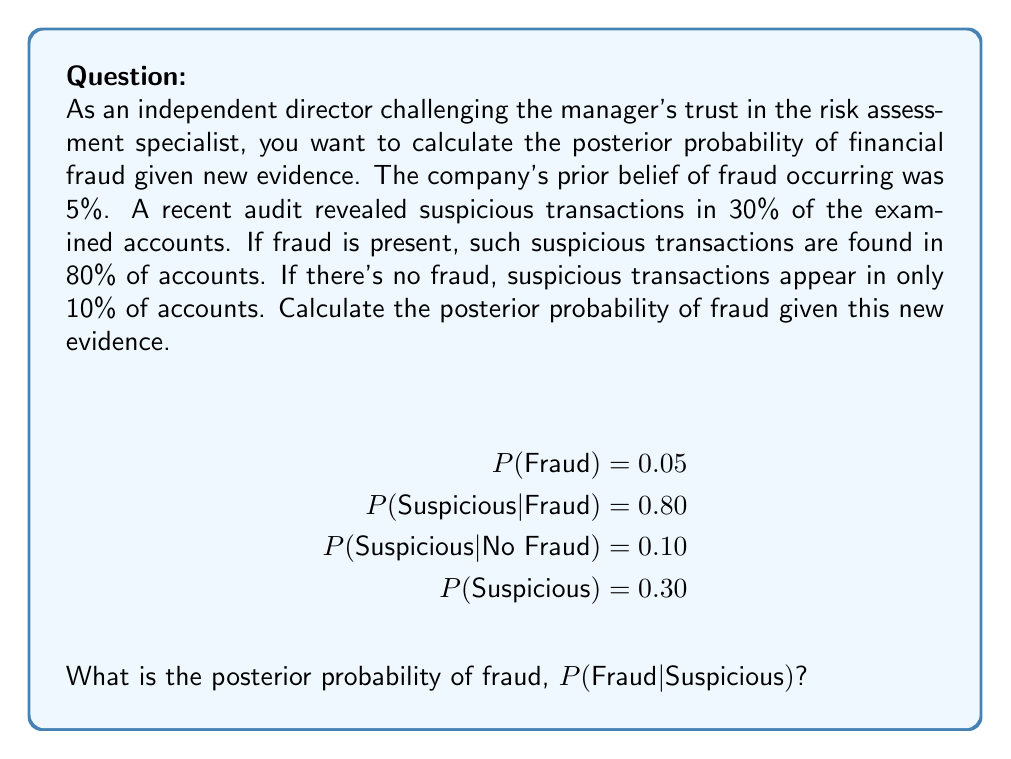Can you answer this question? To solve this problem, we'll use Bayes' Theorem:

$$P(A|B) = \frac{P(B|A) \cdot P(A)}{P(B)}$$

Where:
A = Fraud
B = Suspicious transactions

Step 1: Identify the given probabilities
- $P(\text{Fraud}) = 0.05$
- $P(\text{Suspicious} | \text{Fraud}) = 0.80$
- $P(\text{Suspicious} | \text{No Fraud}) = 0.10$
- $P(\text{Suspicious}) = 0.30$

Step 2: Apply Bayes' Theorem
$$P(\text{Fraud} | \text{Suspicious}) = \frac{P(\text{Suspicious} | \text{Fraud}) \cdot P(\text{Fraud})}{P(\text{Suspicious})}$$

Step 3: Substitute the values
$$P(\text{Fraud} | \text{Suspicious}) = \frac{0.80 \cdot 0.05}{0.30}$$

Step 4: Calculate the result
$$P(\text{Fraud} | \text{Suspicious}) = \frac{0.04}{0.30} = 0.1333...$$

Step 5: Convert to percentage
$$P(\text{Fraud} | \text{Suspicious}) \approx 13.33\%$$

This result shows that given the new evidence of suspicious transactions, the probability of fraud has increased from the prior belief of 5% to approximately 13.33%.
Answer: 13.33% 